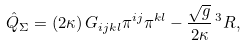Convert formula to latex. <formula><loc_0><loc_0><loc_500><loc_500>\hat { Q } _ { \Sigma } = \left ( 2 \kappa \right ) G _ { i j k l } \pi ^ { i j } \pi ^ { k l } - \frac { \sqrt { g } } { 2 \kappa } \, ^ { 3 } R ,</formula> 